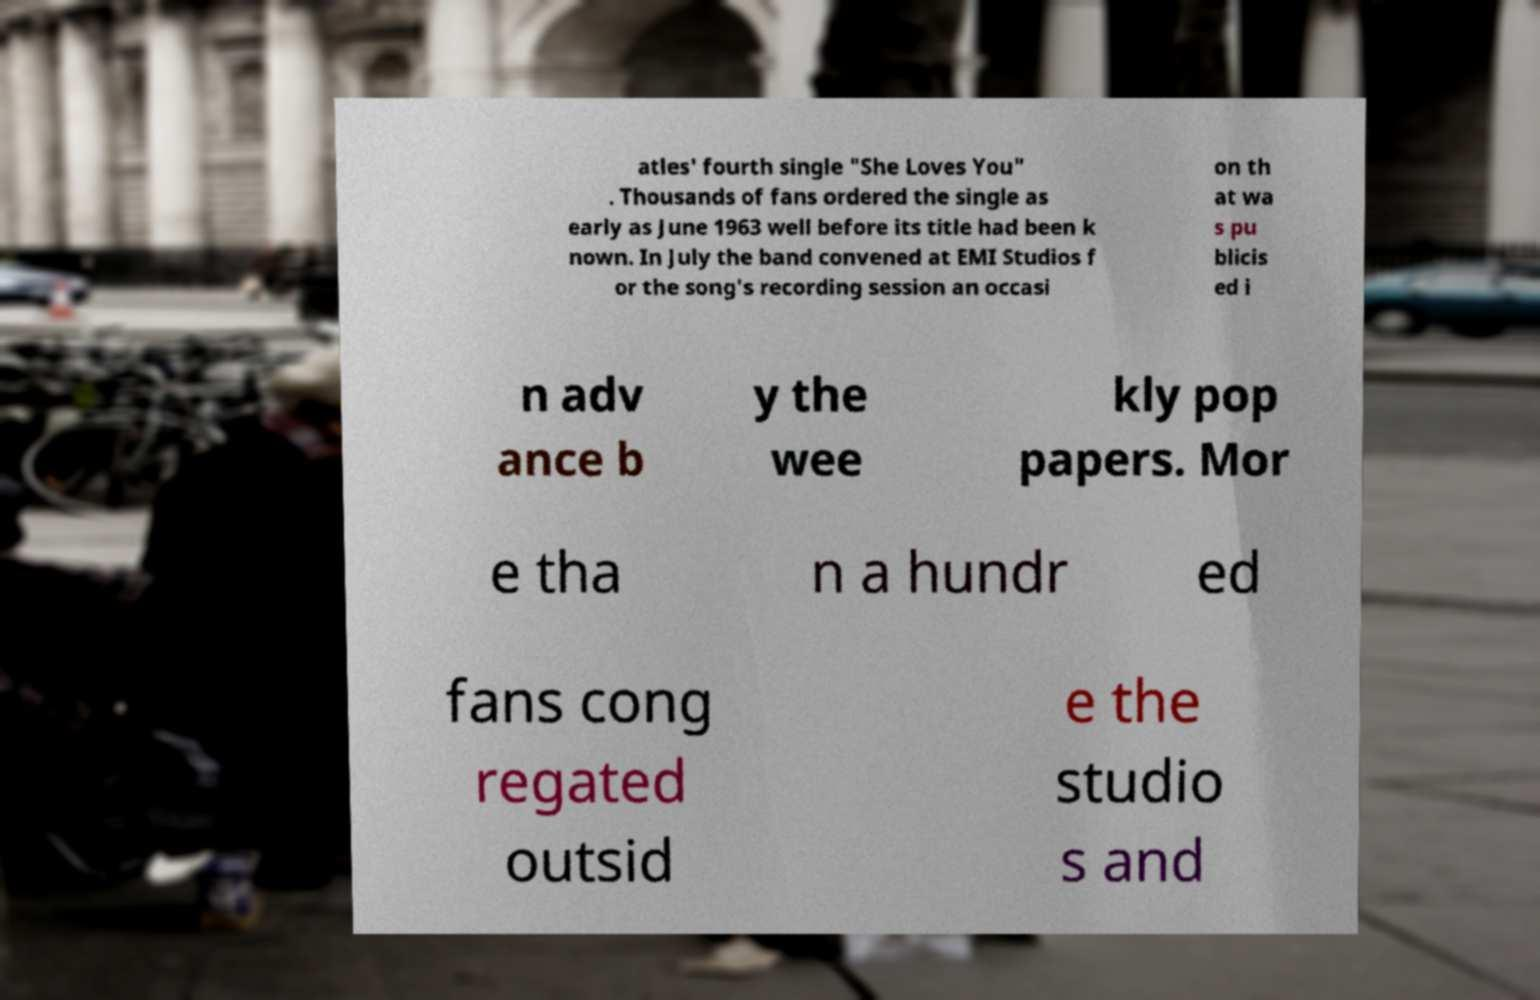For documentation purposes, I need the text within this image transcribed. Could you provide that? atles' fourth single "She Loves You" . Thousands of fans ordered the single as early as June 1963 well before its title had been k nown. In July the band convened at EMI Studios f or the song's recording session an occasi on th at wa s pu blicis ed i n adv ance b y the wee kly pop papers. Mor e tha n a hundr ed fans cong regated outsid e the studio s and 